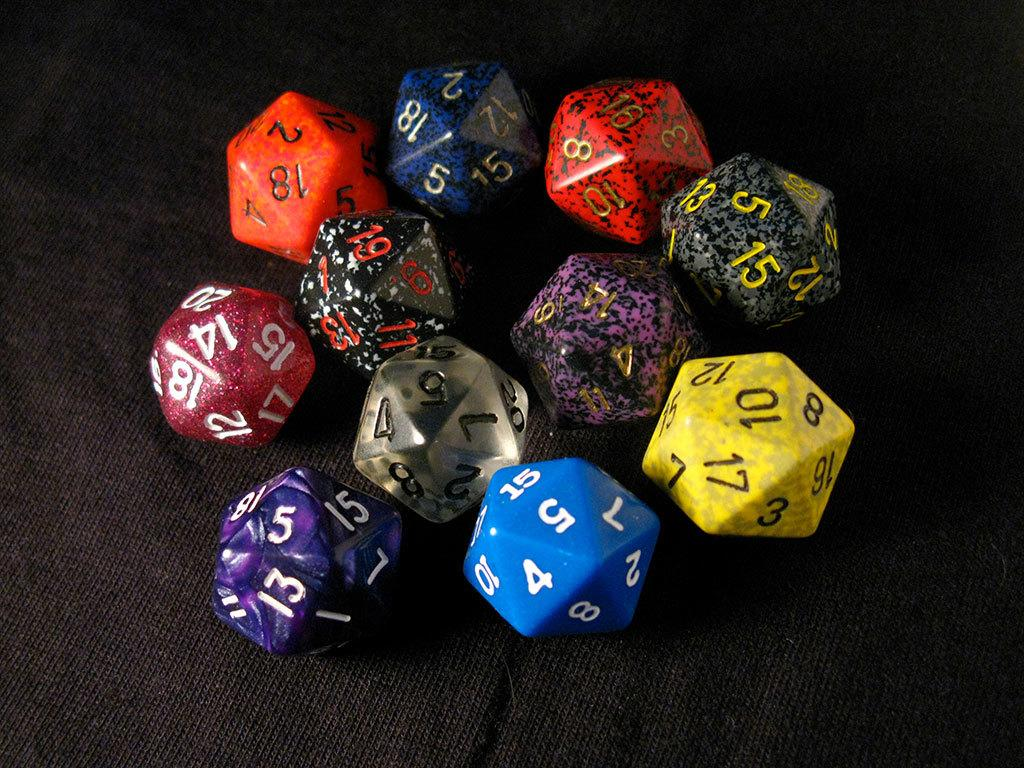What objects are present in the image? There are colorful dice in the image. What is the color of the surface on which the dice are placed? The dice are on a black color surface. What type of cord is attached to the ear of the sack in the image? There is no cord, ear, or sack present in the image; it only features colorful dice on a black surface. 